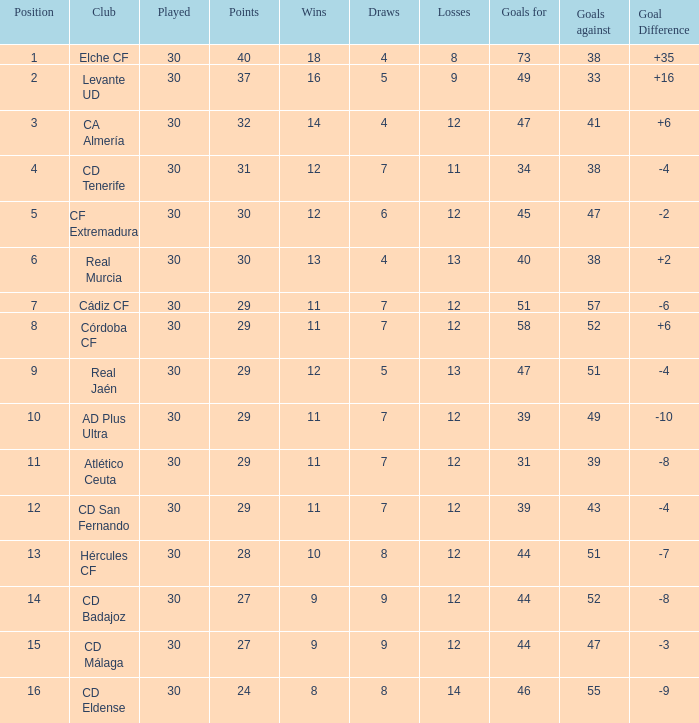What is the quantity of goals having under 14 wins and a goal difference smaller than -4? 51, 39, 31, 44, 44, 46. 